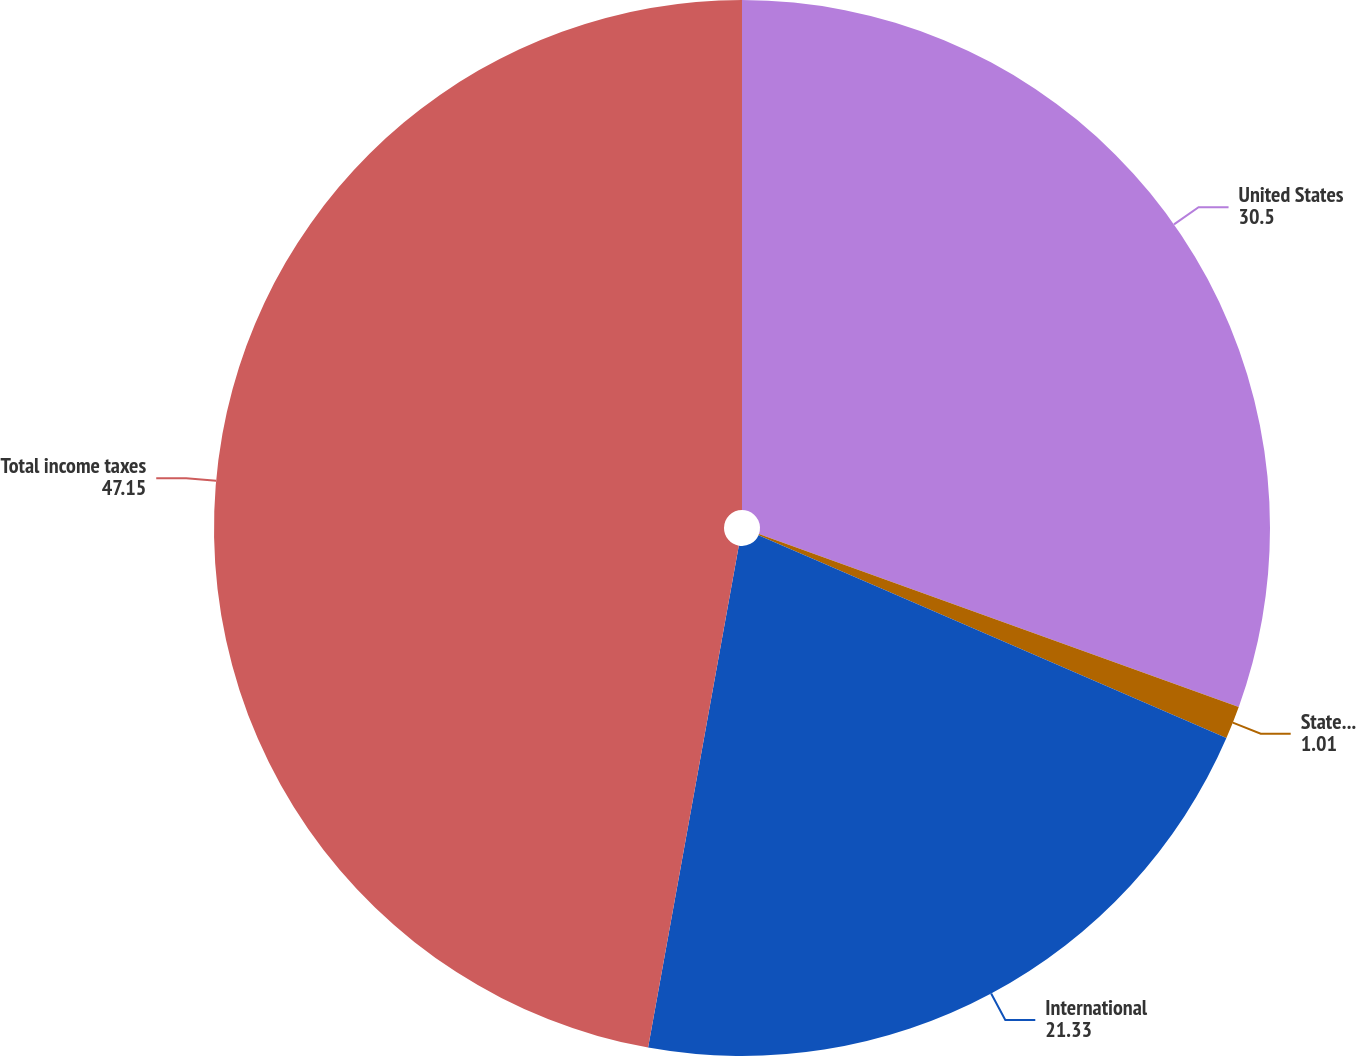Convert chart. <chart><loc_0><loc_0><loc_500><loc_500><pie_chart><fcel>United States<fcel>State and local<fcel>International<fcel>Total income taxes<nl><fcel>30.5%<fcel>1.01%<fcel>21.33%<fcel>47.15%<nl></chart> 